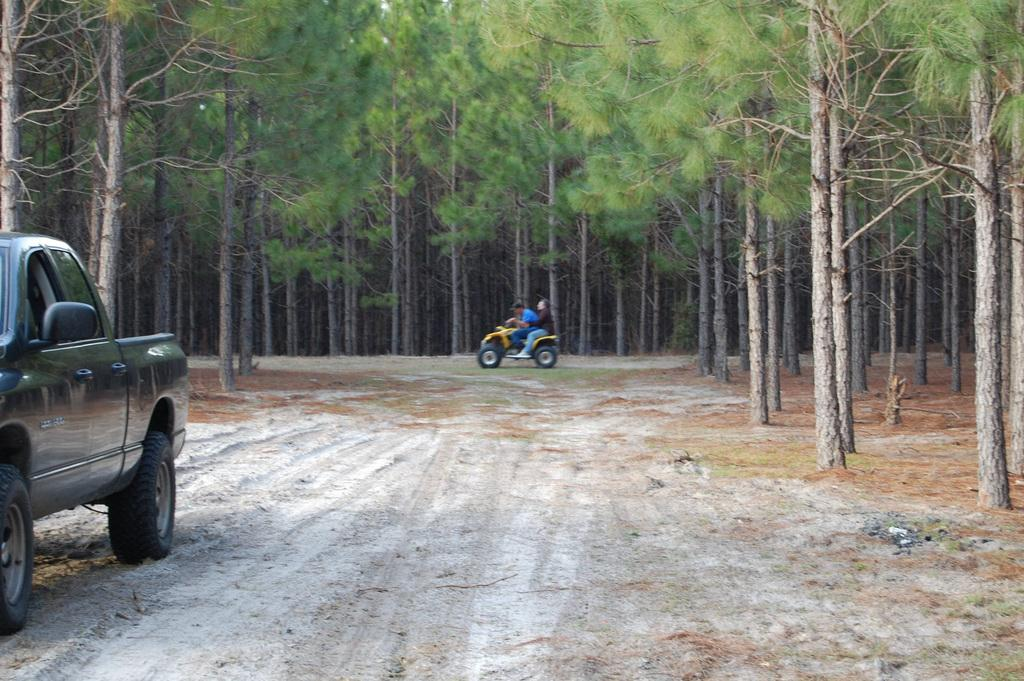What is the main subject in the image? There is a vehicle in the image. Can you describe the people in the image? There are two people sitting on another vehicle in the image. What can be seen in the background of the image? There are many trees in the background of the image. How many children are playing on the iron channel in the image? There are no children or iron channels present in the image. 